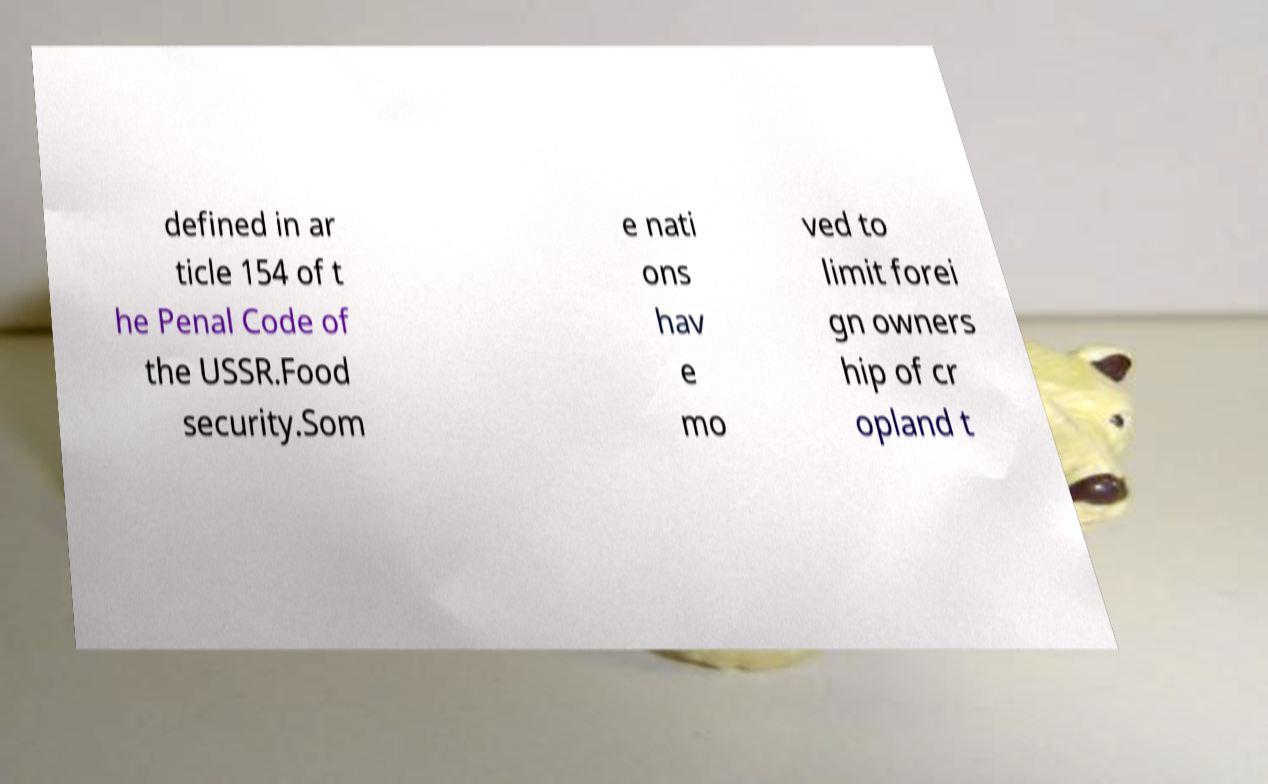For documentation purposes, I need the text within this image transcribed. Could you provide that? defined in ar ticle 154 of t he Penal Code of the USSR.Food security.Som e nati ons hav e mo ved to limit forei gn owners hip of cr opland t 